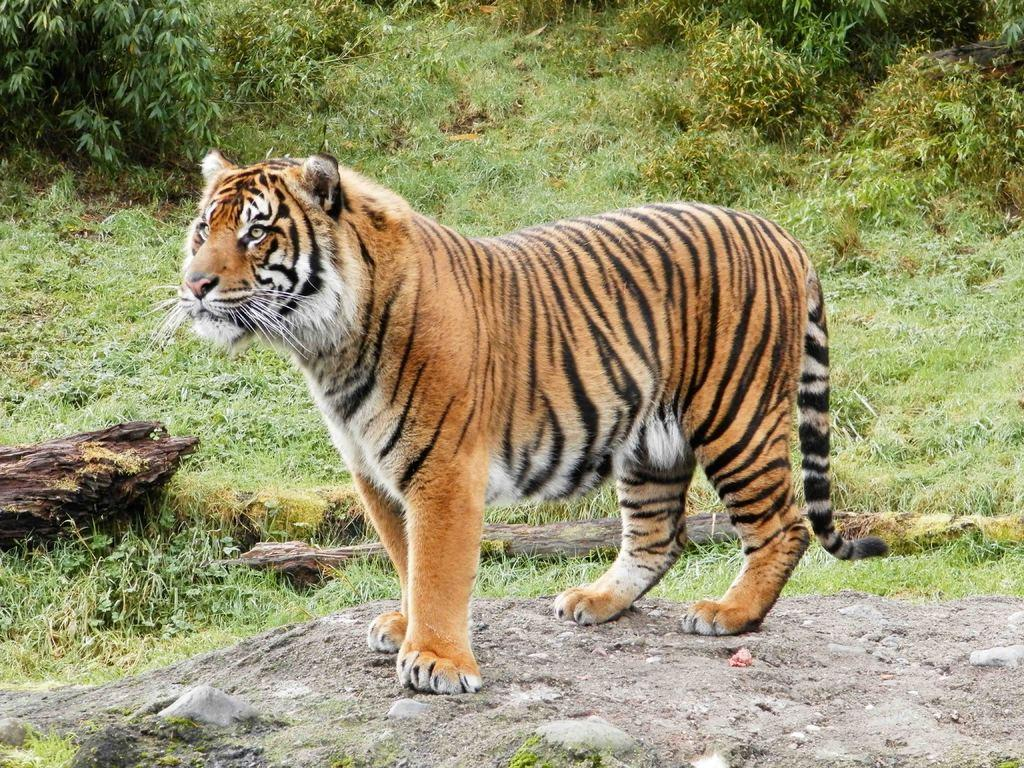What is the main subject in the center of the picture? There is a tiger in the center of the picture. What type of surface is the tiger standing on? The tiger is on a concrete surface. What can be seen in the background of the image? There are plants, grass, wooden logs, and trees in the background of the image. How much water is flowing in the stream in the image? There is no stream present in the image; it features a tiger on a concrete surface with plants, grass, wooden logs, and trees in the background. 